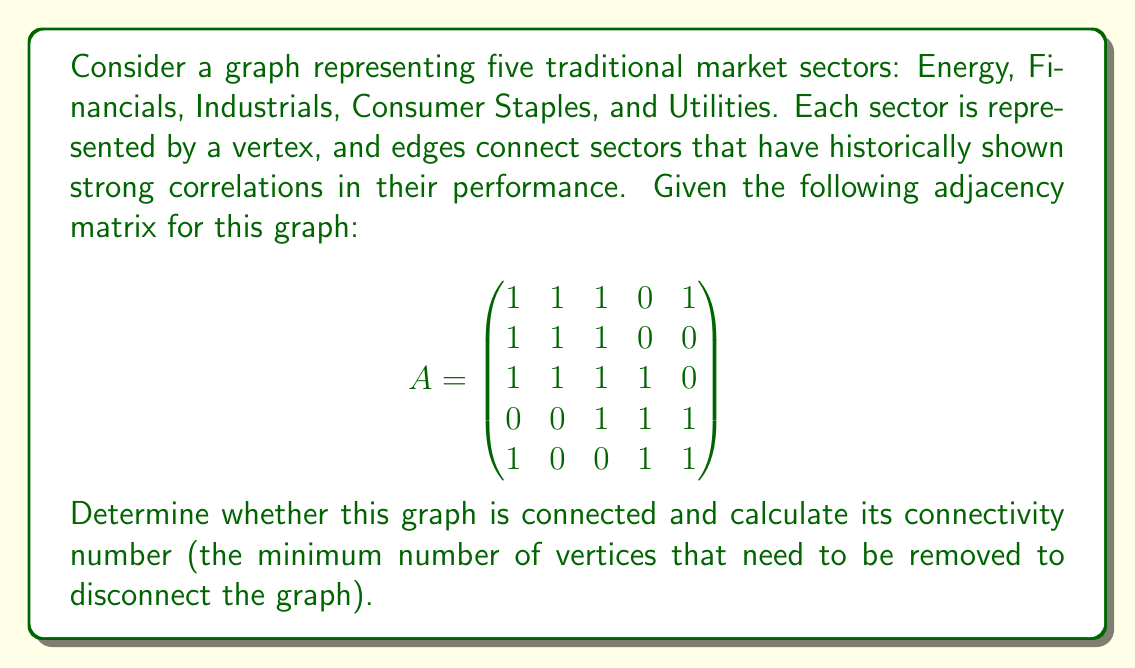What is the answer to this math problem? To solve this problem, we'll follow these steps:

1. Determine if the graph is connected:
   A graph is connected if there exists a path between any two vertices. We can check this by examining the adjacency matrix.

   - Energy (1) is connected to Financials, Industrials, and Utilities
   - Financials (2) is connected to Energy and Industrials
   - Industrials (3) is connected to Energy, Financials, and Consumer Staples
   - Consumer Staples (4) is connected to Industrials and Utilities
   - Utilities (5) is connected to Energy and Consumer Staples

   By tracing these connections, we can see that there is a path between any two vertices. Therefore, the graph is connected.

2. Calculate the connectivity number:
   The connectivity number is the minimum number of vertices that need to be removed to disconnect the graph. To find this, we need to identify the smallest set of vertices that, when removed, would separate the graph into two or more components.

   Let's consider removing each vertex:
   - Removing Energy: The remaining graph is still connected.
   - Removing Financials: The remaining graph is still connected.
   - Removing Industrials: This disconnects the graph into two components:
     {Energy, Financials} and {Consumer Staples, Utilities}
   - Removing Consumer Staples: The remaining graph is still connected.
   - Removing Utilities: The remaining graph is still connected.

   We found that removing just one vertex (Industrials) can disconnect the graph. Therefore, the connectivity number is 1.

This analysis shows that the Industrials sector plays a crucial role in connecting different parts of the traditional market, which aligns with the perspective of a veteran stockbroker who relies on established market relationships.
Answer: The graph is connected, and its connectivity number is 1. 